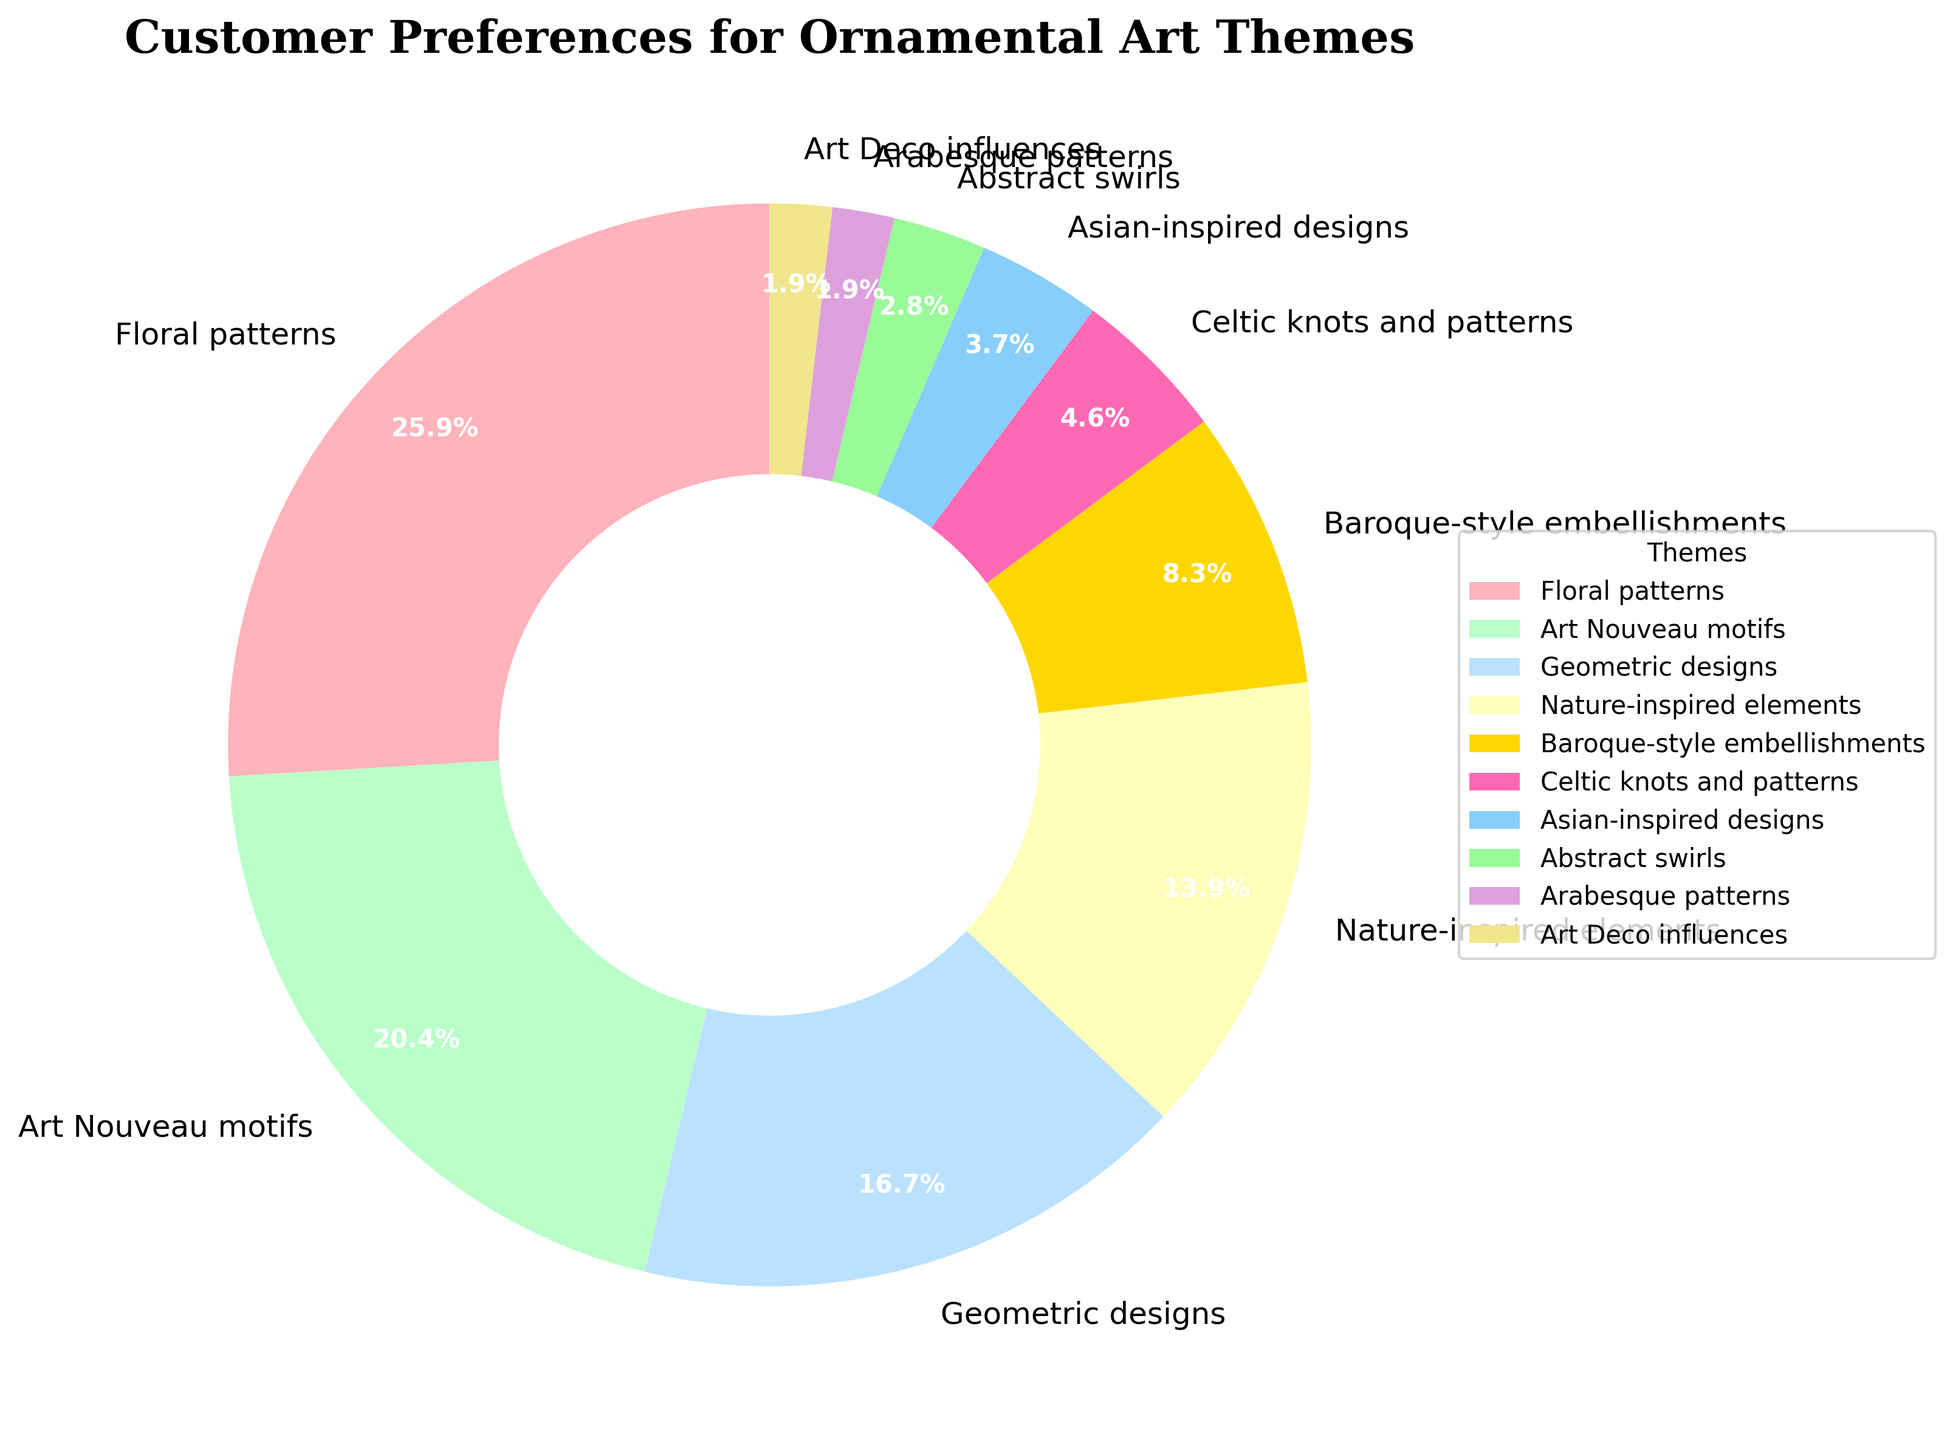What is the most preferred ornamental art theme for home decor products? To determine the most preferred theme, look for the segment with the largest percentage. According to the chart, which shows the distribution of customer preferences, the largest percentage is 28% which corresponds to Floral patterns.
Answer: Floral patterns How much more popular are Art Nouveau motifs compared to Abstract swirls? First, identify the percentages for both themes: Art Nouveau motifs are 22% and Abstract swirls are 3%. Then, calculate the difference by subtracting the smaller percentage from the larger one: 22% - 3% = 19%.
Answer: 19% What is the combined percentage of preferences for Baroque-style embellishments and Art Deco influences? Find the respective percentages from the chart: Baroque-style embellishments are 9% and Art Deco influences are 2%. Sum these percentages to get the combined total: 9% + 2% = 11%.
Answer: 11% Which theme has a higher percentage of preference: Geometric designs or Nature-inspired elements? Compare the percentages of the two themes: Geometric designs have 18%, and Nature-inspired elements have 15%. Since 18% is greater than 15%, Geometric designs have a higher percentage of preference.
Answer: Geometric designs What is the total percentage of preferences for themes that have a percentage of 10% or less each? Identify the themes that fall into this category: Baroque-style embellishments (9%), Celtic knots and patterns (5%), Asian-inspired designs (4%), Abstract swirls (3%), Arabesque patterns (2%), and Art Deco influences (2%). Sum these percentages: 9% + 5% + 4% + 3% + 2% + 2% = 25%.
Answer: 25% How many themes have a preference percentage greater than the average percentage of all themes? First, find the average percentage by summing up all the percentages and dividing by the number of themes: (28 + 22 + 18 + 15 + 9 + 5 + 4 + 3 + 2 + 2) / 10 = 10.8%. Next, count the themes with percentages greater than 10.8%: Floral patterns (28%), Art Nouveau motifs (22%), Geometric designs (18%), and Nature-inspired elements (15%). This gives a total of 4 themes.
Answer: 4 Which two themes combined are closest to representing one-third of the total customer preferences? To find one-third of the total, divide 100% by 3, which equals approximately 33.33%. Look for pairs of themes whose percentages add up to approximately 33.33%. The combination of Art Nouveau motifs (22%) and Nature-inspired elements (15%) gives a total of 22% + 15% = 37%, which is the closest.
Answer: Art Nouveau motifs and Nature-inspired elements What color represents Floral patterns in the pie chart? To identify the color for Floral patterns, refer to the section with the label "Floral patterns" which shows a pinkish shade closest to red among the segments.
Answer: Pink (closest to red) Which theme has the smallest segment, and what is its percentage? Locate the smallest segment by looking for the smallest wedge in the pie chart. The smallest segment is Arabesque patterns, with a percentage of 2%.
Answer: Arabesque patterns, 2% 